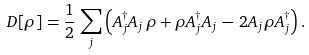Convert formula to latex. <formula><loc_0><loc_0><loc_500><loc_500>D [ \rho ] = \frac { 1 } { 2 } \, \sum _ { j } \left ( A ^ { \dagger } _ { j } A _ { j } \, \rho + \rho A ^ { \dagger } _ { j } A _ { j } \, - \, 2 A _ { j } \rho A _ { j } ^ { \dagger } \right ) .</formula> 